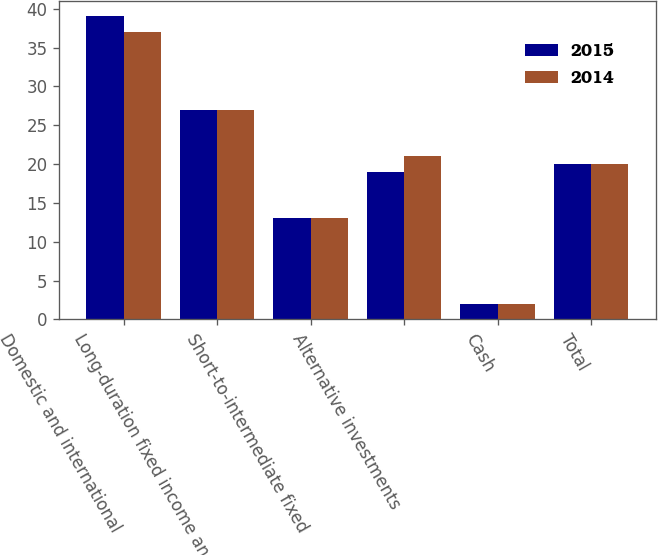Convert chart. <chart><loc_0><loc_0><loc_500><loc_500><stacked_bar_chart><ecel><fcel>Domestic and international<fcel>Long-duration fixed income and<fcel>Short-to-intermediate fixed<fcel>Alternative investments<fcel>Cash<fcel>Total<nl><fcel>2015<fcel>39<fcel>27<fcel>13<fcel>19<fcel>2<fcel>20<nl><fcel>2014<fcel>37<fcel>27<fcel>13<fcel>21<fcel>2<fcel>20<nl></chart> 